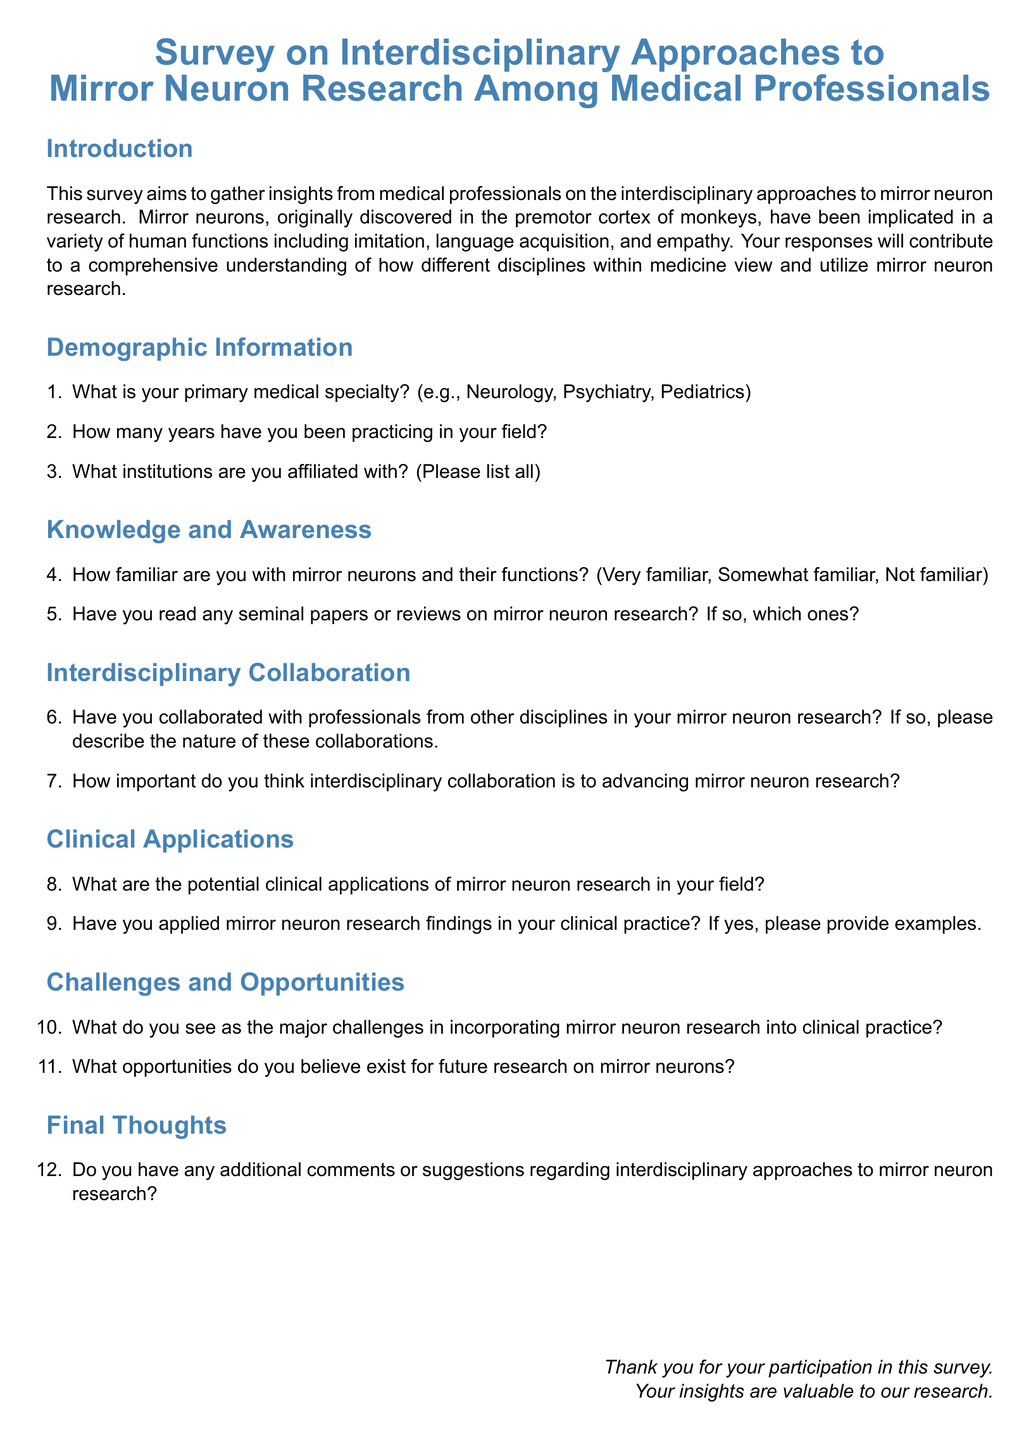What is the primary subject of the survey? The survey focuses on interdisciplinary approaches to mirror neuron research.
Answer: Interdisciplinary approaches to mirror neuron research How many sections are present in the document? The document contains multiple sections including an introduction, demographic information, knowledge and awareness, interdisciplinary collaboration, clinical applications, challenges and opportunities, and final thoughts.
Answer: 7 What type of professionals is the survey targeting? The survey aims to gather insights from medical professionals.
Answer: Medical professionals What is one of the potential clinical applications of mirror neuron research mentioned? The specific applications are not stated in the document, as it prompts respondents to provide their insights.
Answer: Open-ended What color is used for the headings in the document? The headings use a specific shade of blue described as neuron blue.
Answer: Neuron blue How familiar are participants with mirror neurons expected to rate themselves? Participants can categorize themselves as very familiar, somewhat familiar, or not familiar with mirror neurons.
Answer: Very familiar, somewhat familiar, not familiar How does the document conclude? The document concludes with a thank you message to participants for their participation.
Answer: Thank you for your participation in this survey 